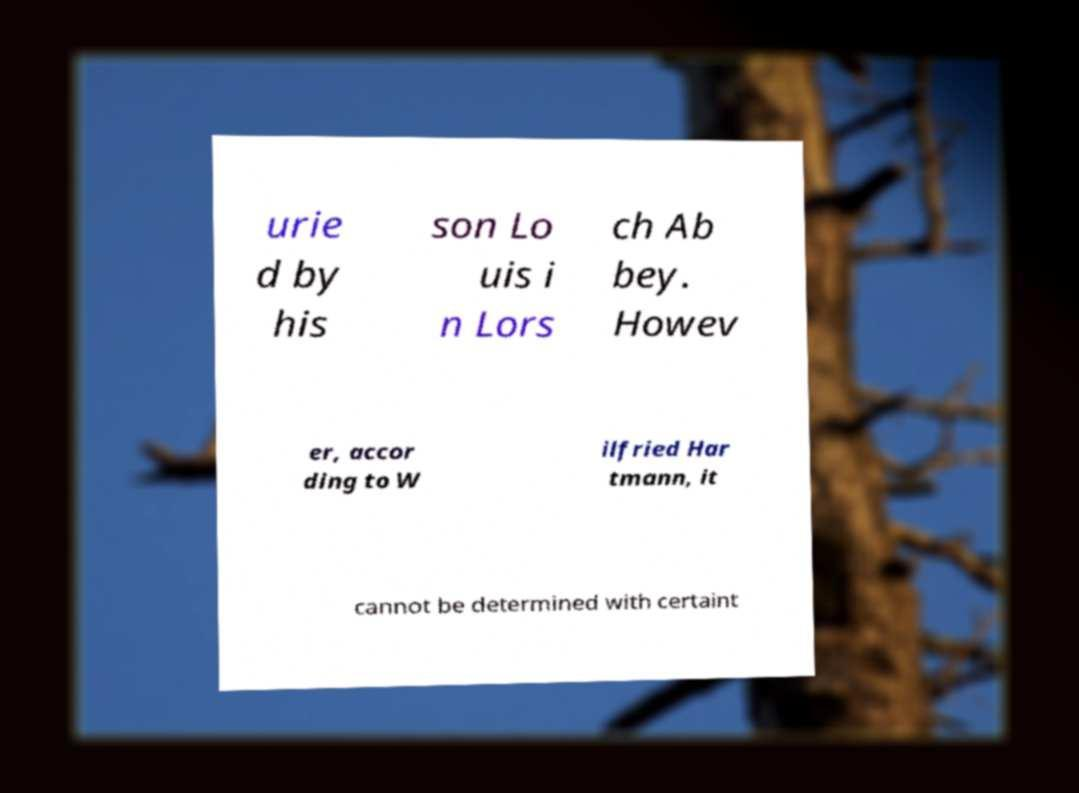There's text embedded in this image that I need extracted. Can you transcribe it verbatim? urie d by his son Lo uis i n Lors ch Ab bey. Howev er, accor ding to W ilfried Har tmann, it cannot be determined with certaint 